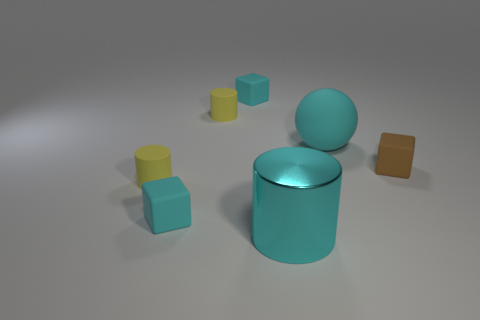Add 1 tiny green shiny cylinders. How many objects exist? 8 Subtract all matte cylinders. How many cylinders are left? 1 Subtract all cyan cubes. How many cubes are left? 1 Subtract all cylinders. How many objects are left? 4 Subtract all gray balls. How many brown cylinders are left? 0 Subtract all gray cylinders. Subtract all brown matte objects. How many objects are left? 6 Add 2 yellow rubber things. How many yellow rubber things are left? 4 Add 3 tiny yellow objects. How many tiny yellow objects exist? 5 Subtract 0 gray cylinders. How many objects are left? 7 Subtract 2 cylinders. How many cylinders are left? 1 